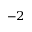<formula> <loc_0><loc_0><loc_500><loc_500>^ { - 2 }</formula> 